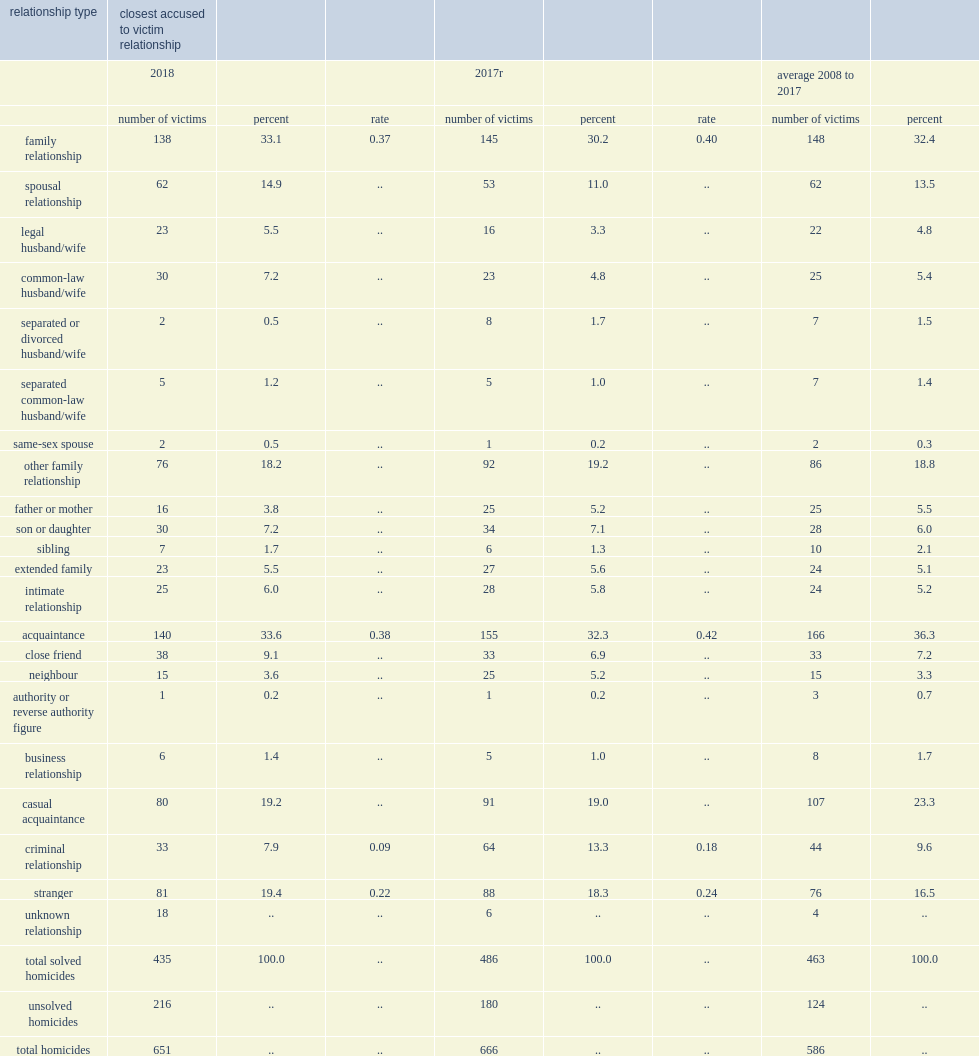What was the percentage of victims of solved homicides in 2018 knew their killer? 82. What were the percentages of homicide victims killed by an acquaintance and by a family member respectively? 33.6 33.1. What were the changes in the number of victims committed by other family members , intimate partners and acquaintances respectively from 2017 to 2018? -16 -3 -15. 